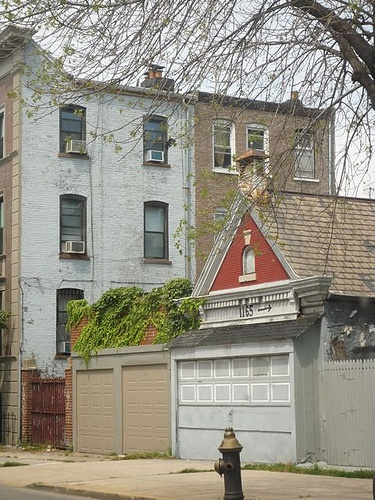Describe the objects in this image and their specific colors. I can see a fire hydrant in lightgray, black, gray, and tan tones in this image. 